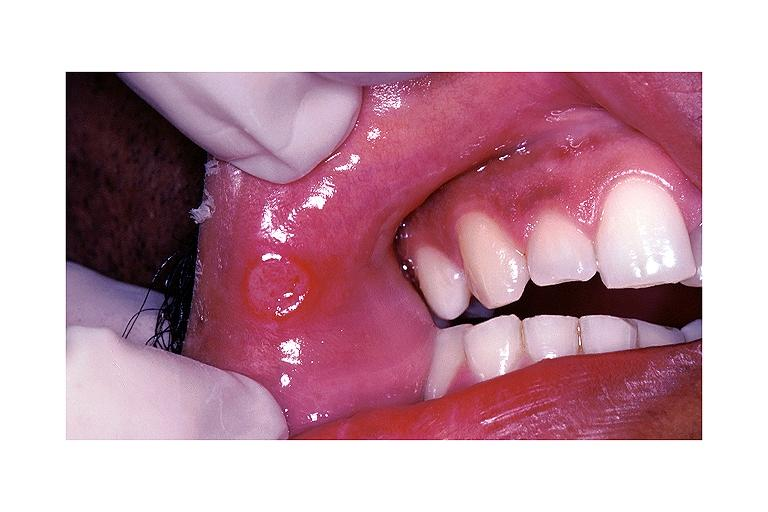what is present?
Answer the question using a single word or phrase. Oral 